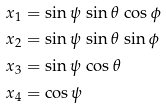<formula> <loc_0><loc_0><loc_500><loc_500>x _ { 1 } & = \sin \psi \, \sin \theta \, \cos \phi \\ x _ { 2 } & = \sin \psi \, \sin \theta \, \sin \phi \\ x _ { 3 } & = \sin \psi \, \cos \theta \\ x _ { 4 } & = \cos \psi</formula> 